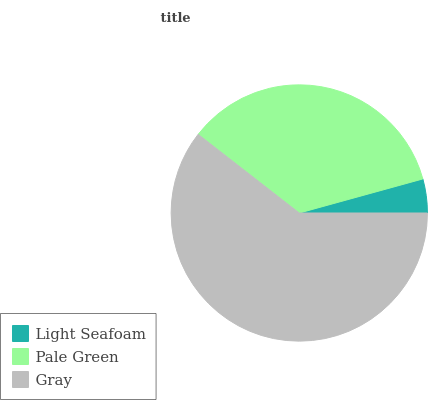Is Light Seafoam the minimum?
Answer yes or no. Yes. Is Gray the maximum?
Answer yes or no. Yes. Is Pale Green the minimum?
Answer yes or no. No. Is Pale Green the maximum?
Answer yes or no. No. Is Pale Green greater than Light Seafoam?
Answer yes or no. Yes. Is Light Seafoam less than Pale Green?
Answer yes or no. Yes. Is Light Seafoam greater than Pale Green?
Answer yes or no. No. Is Pale Green less than Light Seafoam?
Answer yes or no. No. Is Pale Green the high median?
Answer yes or no. Yes. Is Pale Green the low median?
Answer yes or no. Yes. Is Light Seafoam the high median?
Answer yes or no. No. Is Gray the low median?
Answer yes or no. No. 